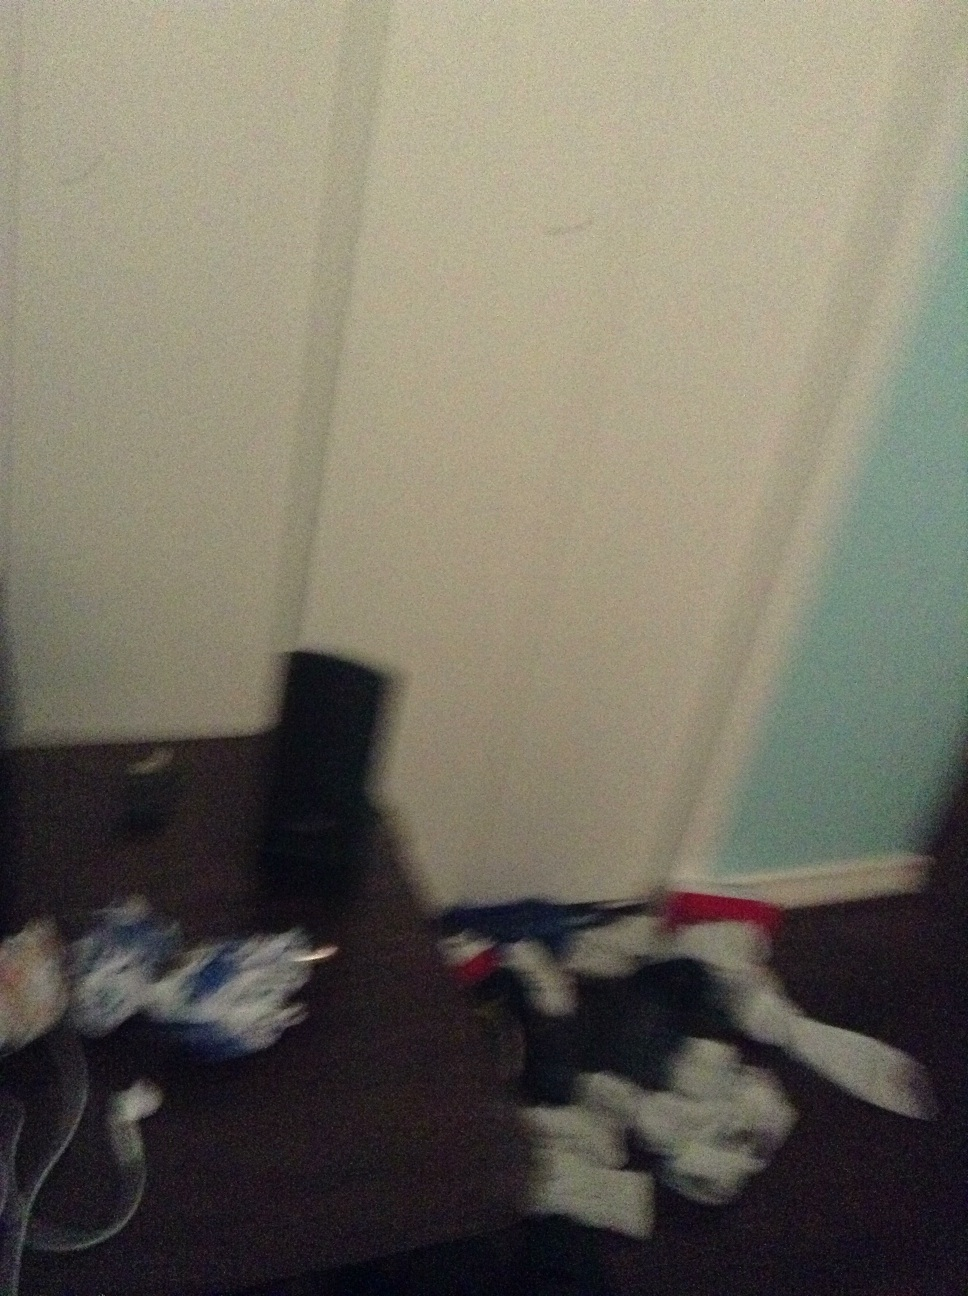This image seems a bit cluttered. What might be a reason for the appearance? The cluttered appearance of the room might suggest it is either a storage space or currently not in active use. It's also possible that the room was photographed in a hurry or during a moment of disorder such as moving or redecorating phases. This can occasionally make spaces appear more chaotic than usual. 